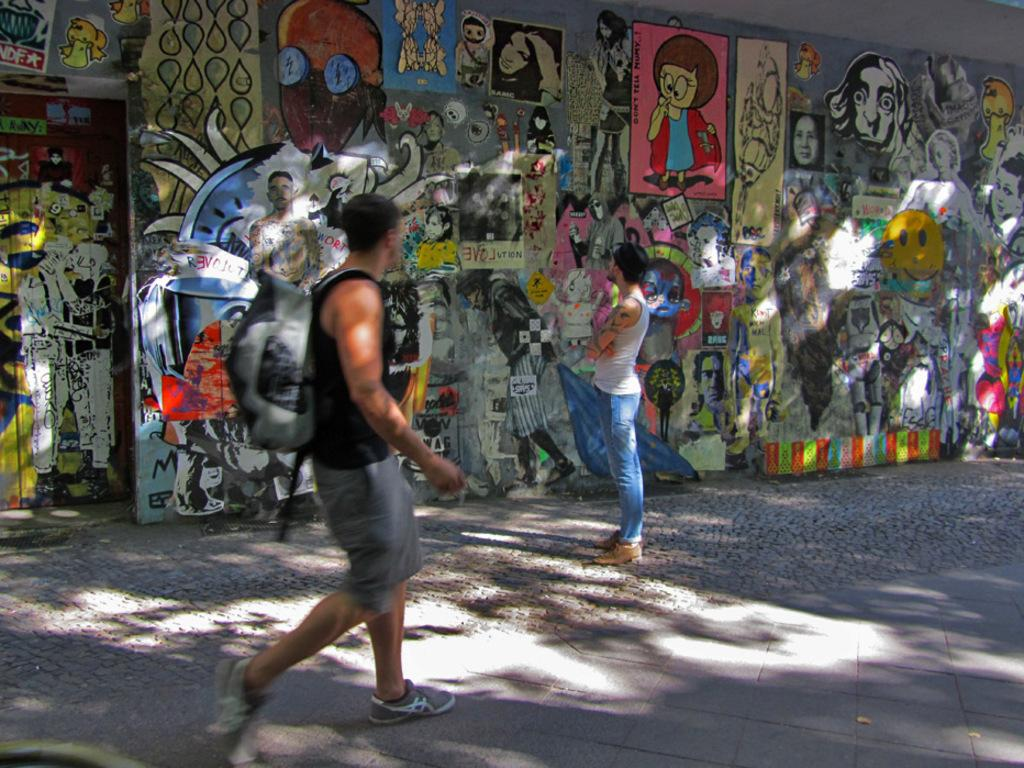What is the main subject of the image? There is a man walking on the road in the image. Can you describe the second man in the image? There is another man standing behind the first man. What can be seen in the background of the image? There is a wall in the background of the image. What is on the wall in the image? There are paintings and papers sticked on the wall. What type of vessel can be seen sailing in the afternoon in the image? There is no vessel or indication of time in the image; it features two men walking on a road with a wall in the background. 